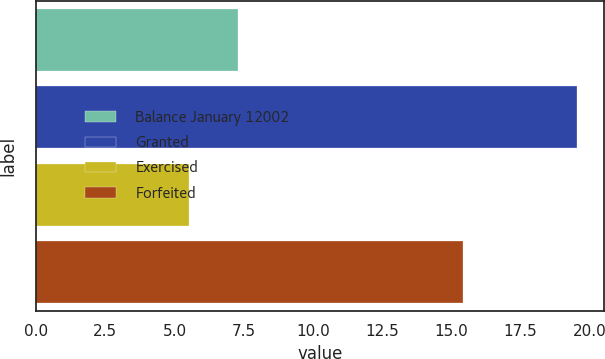<chart> <loc_0><loc_0><loc_500><loc_500><bar_chart><fcel>Balance January 12002<fcel>Granted<fcel>Exercised<fcel>Forfeited<nl><fcel>7.31<fcel>19.55<fcel>5.52<fcel>15.44<nl></chart> 